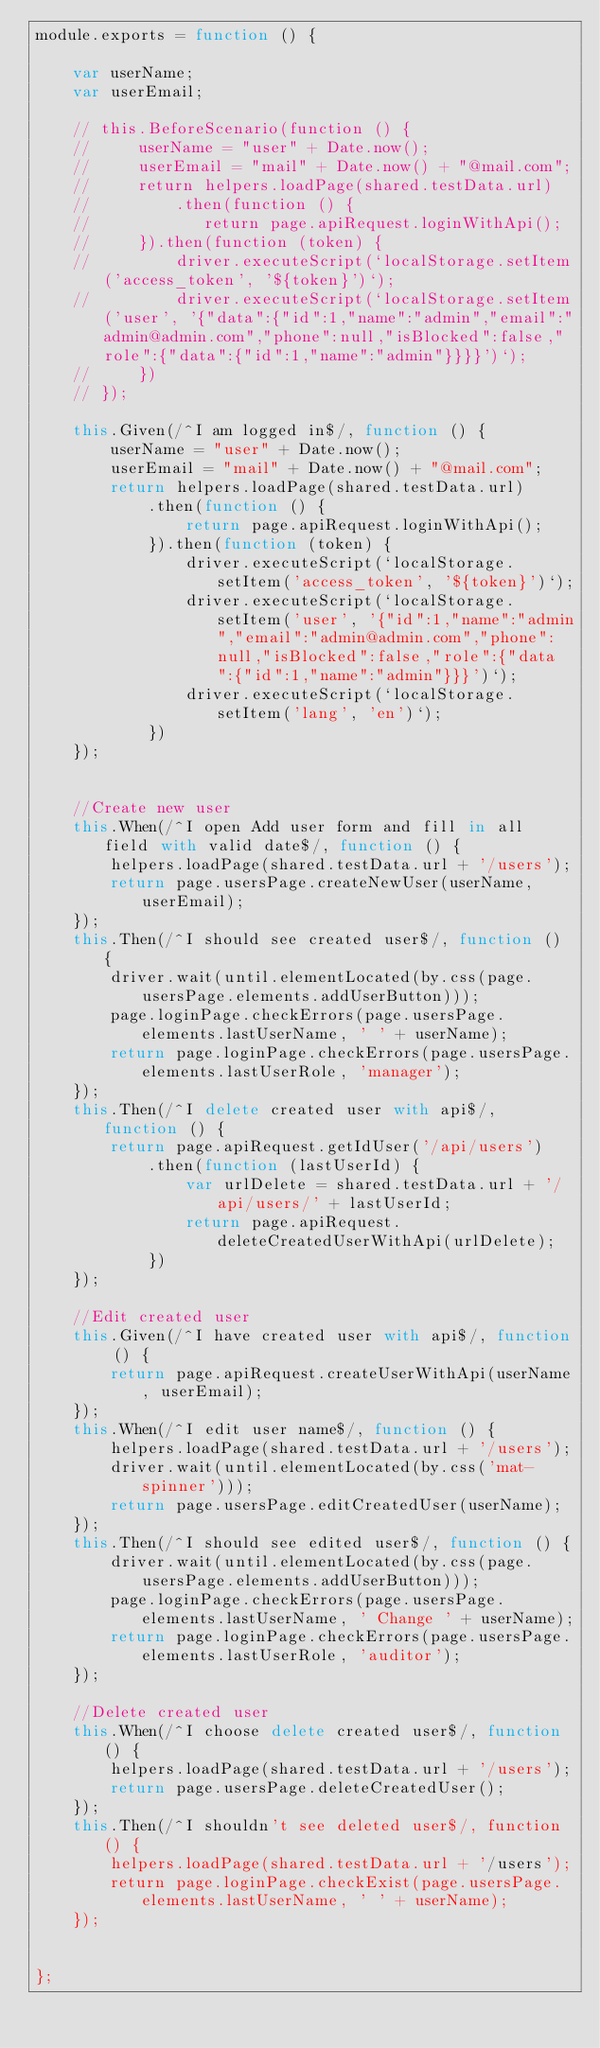Convert code to text. <code><loc_0><loc_0><loc_500><loc_500><_JavaScript_>module.exports = function () {

    var userName;
    var userEmail;

    // this.BeforeScenario(function () {
    //     userName = "user" + Date.now();
    //     userEmail = "mail" + Date.now() + "@mail.com";
    //     return helpers.loadPage(shared.testData.url)
    //         .then(function () {
    //            return page.apiRequest.loginWithApi();
    //     }).then(function (token) {
    //         driver.executeScript(`localStorage.setItem('access_token', '${token}')`);
    //         driver.executeScript(`localStorage.setItem('user', '{"data":{"id":1,"name":"admin","email":"admin@admin.com","phone":null,"isBlocked":false,"role":{"data":{"id":1,"name":"admin"}}}}')`);
    //     })
    // });

    this.Given(/^I am logged in$/, function () {
        userName = "user" + Date.now();
        userEmail = "mail" + Date.now() + "@mail.com";
        return helpers.loadPage(shared.testData.url)
            .then(function () {
                return page.apiRequest.loginWithApi();
            }).then(function (token) {
                driver.executeScript(`localStorage.setItem('access_token', '${token}')`);
                driver.executeScript(`localStorage.setItem('user', '{"id":1,"name":"admin","email":"admin@admin.com","phone":null,"isBlocked":false,"role":{"data":{"id":1,"name":"admin"}}}')`);
                driver.executeScript(`localStorage.setItem('lang', 'en')`);
            })
    });


    //Create new user
    this.When(/^I open Add user form and fill in all field with valid date$/, function () {
        helpers.loadPage(shared.testData.url + '/users');
        return page.usersPage.createNewUser(userName, userEmail);
    });
    this.Then(/^I should see created user$/, function () {
        driver.wait(until.elementLocated(by.css(page.usersPage.elements.addUserButton)));
        page.loginPage.checkErrors(page.usersPage.elements.lastUserName, ' ' + userName);
        return page.loginPage.checkErrors(page.usersPage.elements.lastUserRole, 'manager');
    });
    this.Then(/^I delete created user with api$/, function () {
        return page.apiRequest.getIdUser('/api/users')
            .then(function (lastUserId) {
                var urlDelete = shared.testData.url + '/api/users/' + lastUserId;
                return page.apiRequest.deleteCreatedUserWithApi(urlDelete);
            })
    });

    //Edit created user
    this.Given(/^I have created user with api$/, function () {
        return page.apiRequest.createUserWithApi(userName, userEmail);
    });
    this.When(/^I edit user name$/, function () {
        helpers.loadPage(shared.testData.url + '/users');
        driver.wait(until.elementLocated(by.css('mat-spinner')));
        return page.usersPage.editCreatedUser(userName);
    });
    this.Then(/^I should see edited user$/, function () {
        driver.wait(until.elementLocated(by.css(page.usersPage.elements.addUserButton)));
        page.loginPage.checkErrors(page.usersPage.elements.lastUserName, ' Change ' + userName);
        return page.loginPage.checkErrors(page.usersPage.elements.lastUserRole, 'auditor');
    });

    //Delete created user
    this.When(/^I choose delete created user$/, function () {
        helpers.loadPage(shared.testData.url + '/users');
        return page.usersPage.deleteCreatedUser();
    });
    this.Then(/^I shouldn't see deleted user$/, function () {
        helpers.loadPage(shared.testData.url + '/users');
        return page.loginPage.checkExist(page.usersPage.elements.lastUserName, ' ' + userName);
    });


};</code> 